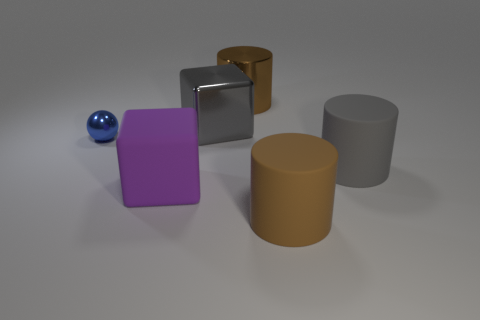What number of large cubes are behind the brown metal cylinder?
Offer a terse response. 0. There is a cube to the right of the large purple thing; is it the same color as the large shiny cylinder?
Your answer should be very brief. No. What number of brown things are large matte cylinders or cylinders?
Your answer should be very brief. 2. The cube in front of the gray object that is behind the large gray rubber cylinder is what color?
Ensure brevity in your answer.  Purple. There is a cylinder that is the same color as the big metal block; what is it made of?
Ensure brevity in your answer.  Rubber. What color is the cube that is behind the small object?
Your response must be concise. Gray. There is a cylinder that is in front of the gray matte object; does it have the same size as the purple matte block?
Provide a succinct answer. Yes. What size is the cylinder that is the same color as the big metal block?
Make the answer very short. Large. Are there any brown metallic things of the same size as the brown rubber cylinder?
Your response must be concise. Yes. Do the block that is in front of the tiny metal thing and the large block behind the small blue metal object have the same color?
Your answer should be very brief. No. 